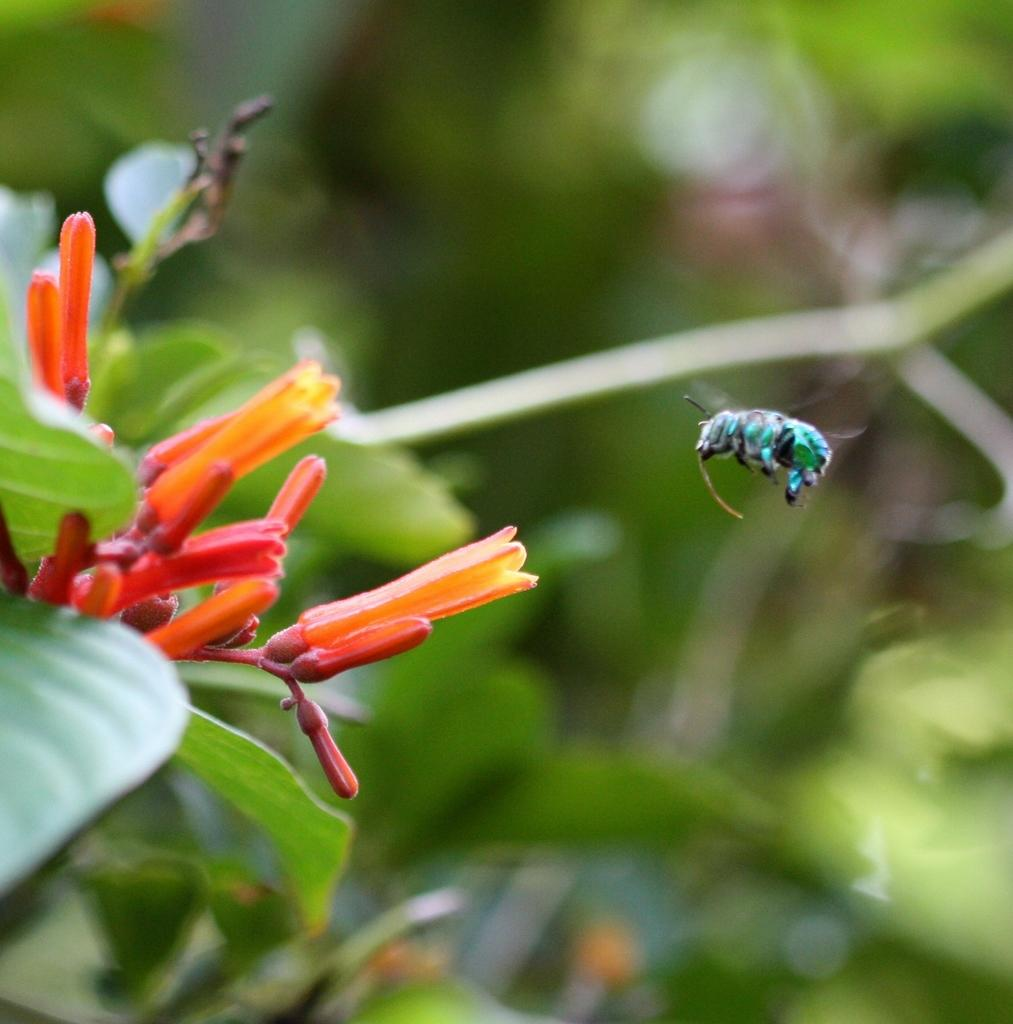What is present in the image that can fly? There is a fly in the image. What type of flora can be seen in the image? There are flowers and plants in the image. Based on the presence of sunlight or shadows, can you determine the time of day the image was taken? The image was likely taken during the day, as there is no indication of darkness or artificial lighting. What type of lettuce is being used as a ring in the image? There is no lettuce or ring present in the image. How many pigs can be seen playing with the flowers in the image? There are no pigs present in the image; it features a fly and plants. 